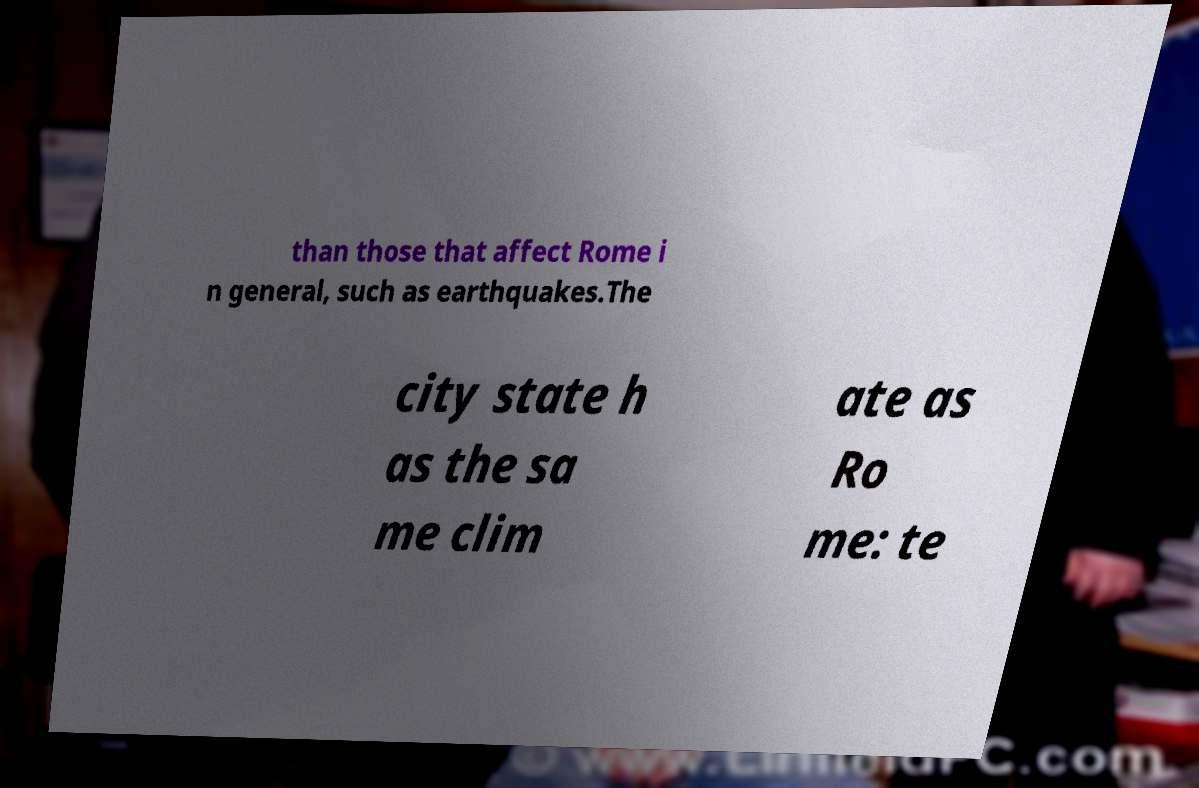I need the written content from this picture converted into text. Can you do that? than those that affect Rome i n general, such as earthquakes.The city state h as the sa me clim ate as Ro me: te 